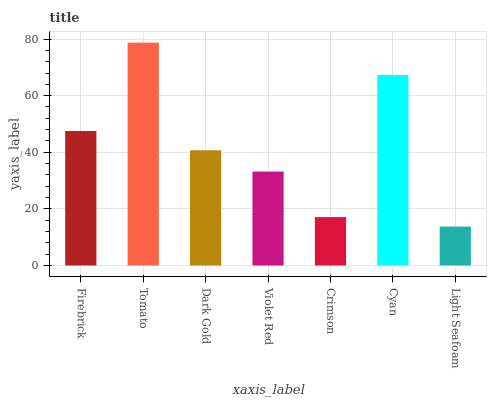Is Light Seafoam the minimum?
Answer yes or no. Yes. Is Tomato the maximum?
Answer yes or no. Yes. Is Dark Gold the minimum?
Answer yes or no. No. Is Dark Gold the maximum?
Answer yes or no. No. Is Tomato greater than Dark Gold?
Answer yes or no. Yes. Is Dark Gold less than Tomato?
Answer yes or no. Yes. Is Dark Gold greater than Tomato?
Answer yes or no. No. Is Tomato less than Dark Gold?
Answer yes or no. No. Is Dark Gold the high median?
Answer yes or no. Yes. Is Dark Gold the low median?
Answer yes or no. Yes. Is Tomato the high median?
Answer yes or no. No. Is Violet Red the low median?
Answer yes or no. No. 